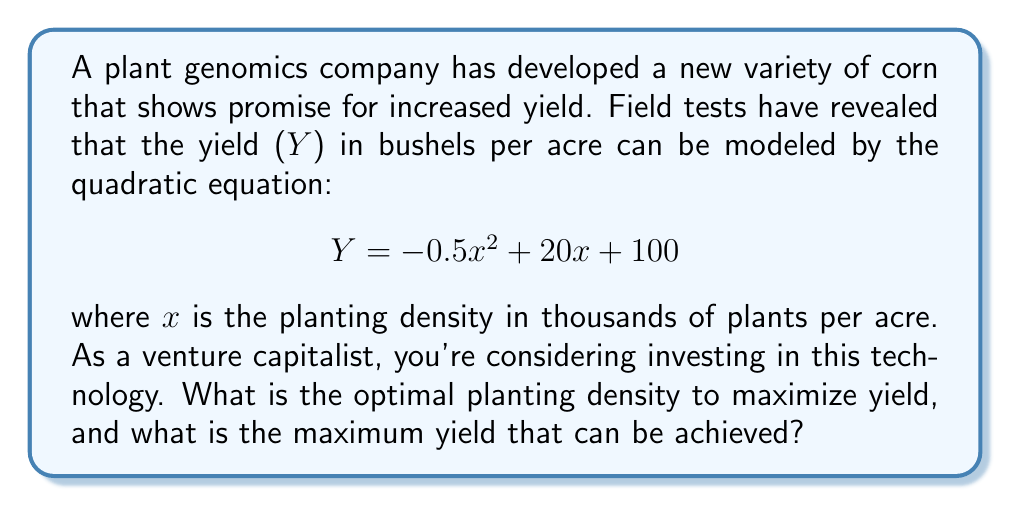Give your solution to this math problem. To solve this problem, we need to follow these steps:

1. Recognize that the yield (Y) is a quadratic function of planting density (x).
2. Recall that the maximum or minimum of a quadratic function occurs at the vertex of the parabola.
3. Use the formula for the x-coordinate of the vertex: $x = -\frac{b}{2a}$, where a and b are the coefficients of the quadratic equation in standard form $(ax^2 + bx + c)$.
4. Calculate the optimal planting density (x) using this formula.
5. Determine the maximum yield by plugging the optimal x value back into the original equation.

Let's proceed:

1. Our quadratic equation is $Y = -0.5x^2 + 20x + 100$

2. Comparing to the standard form $ax^2 + bx + c$:
   $a = -0.5$
   $b = 20$
   $c = 100$

3. Using the vertex formula:
   $$x = -\frac{b}{2a} = -\frac{20}{2(-0.5)} = -\frac{20}{-1} = 20$$

4. The optimal planting density is 20 thousand plants per acre.

5. To find the maximum yield, we substitute x = 20 into the original equation:

   $$\begin{align}
   Y &= -0.5(20)^2 + 20(20) + 100 \\
   &= -0.5(400) + 400 + 100 \\
   &= -200 + 400 + 100 \\
   &= 300
   \end{align}$$

Therefore, the maximum yield is 300 bushels per acre.
Answer: The optimal planting density is 20,000 plants per acre, which will result in a maximum yield of 300 bushels per acre. 